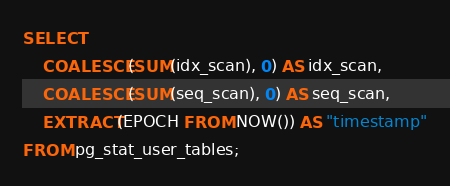Convert code to text. <code><loc_0><loc_0><loc_500><loc_500><_SQL_>SELECT
    COALESCE(SUM(idx_scan), 0) AS idx_scan,
    COALESCE(SUM(seq_scan), 0) AS seq_scan,
    EXTRACT(EPOCH FROM NOW()) AS "timestamp"
FROM pg_stat_user_tables;
</code> 